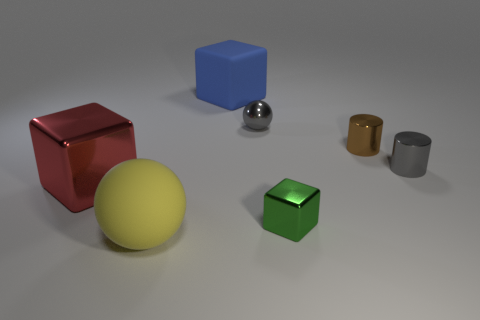Is the number of things that are behind the large yellow thing greater than the number of blue matte cylinders?
Your response must be concise. Yes. Are the small block and the tiny brown cylinder made of the same material?
Give a very brief answer. Yes. How many other objects are there of the same shape as the tiny green object?
Provide a short and direct response. 2. Are there any other things that have the same material as the tiny gray ball?
Give a very brief answer. Yes. What color is the rubber thing that is in front of the rubber thing that is behind the ball left of the large blue matte object?
Ensure brevity in your answer.  Yellow. Do the small metallic object in front of the large shiny cube and the brown object have the same shape?
Keep it short and to the point. No. What number of tiny shiny cubes are there?
Offer a terse response. 1. What number of other metal things have the same size as the green object?
Offer a very short reply. 3. What is the big ball made of?
Keep it short and to the point. Rubber. There is a metallic sphere; is its color the same as the tiny metal cylinder that is in front of the small brown shiny object?
Offer a very short reply. Yes. 